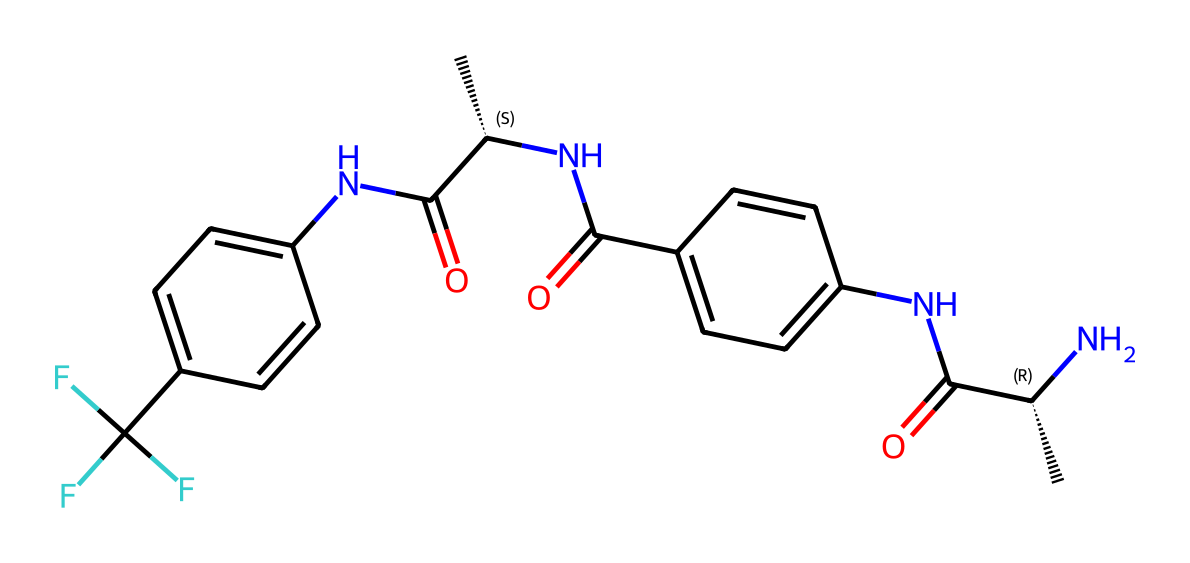What is the primary functional group present in this chemical? The functional groups can be identified by examining the structure. In this SMILES representation, the presence of "-C(=O)N-" indicates an amide functional group, as it contains a carbonyl (C=O) connected to a nitrogen atom (N).
Answer: amide How many rings are present in this chemical structure? By examining the structure, we can identify the cyclic components. In this case, there are two benzene rings, each contributing one ring structure, indicated by the 'c' in the SMILES which signifies aromatic carbon atoms.
Answer: 2 What element is heavily represented in the chemical structure? Analyzing the SMILES notation, we can count the occurrences of different elements. The carbon (C) atoms appear the most frequently in the structure compared to other elements.
Answer: carbon What is the highest oxidation state of the nitrogen atoms in this chemical? To find the oxidation state, we need to analyze the bonding environment of nitrogen within the structure. The nitrogen atoms are primarily part of amide functional groups and are typically in a +1 oxidation state in this context.
Answer: +1 Identify the type of fiber that this chemical is most commonly associated with. Given that this chemical is an aramid, a type of synthetic fiber known for its strength and thermal stability, we can identify it as such based on its structure, which is typical of aramid fibers used in protective wear.
Answer: aramid 